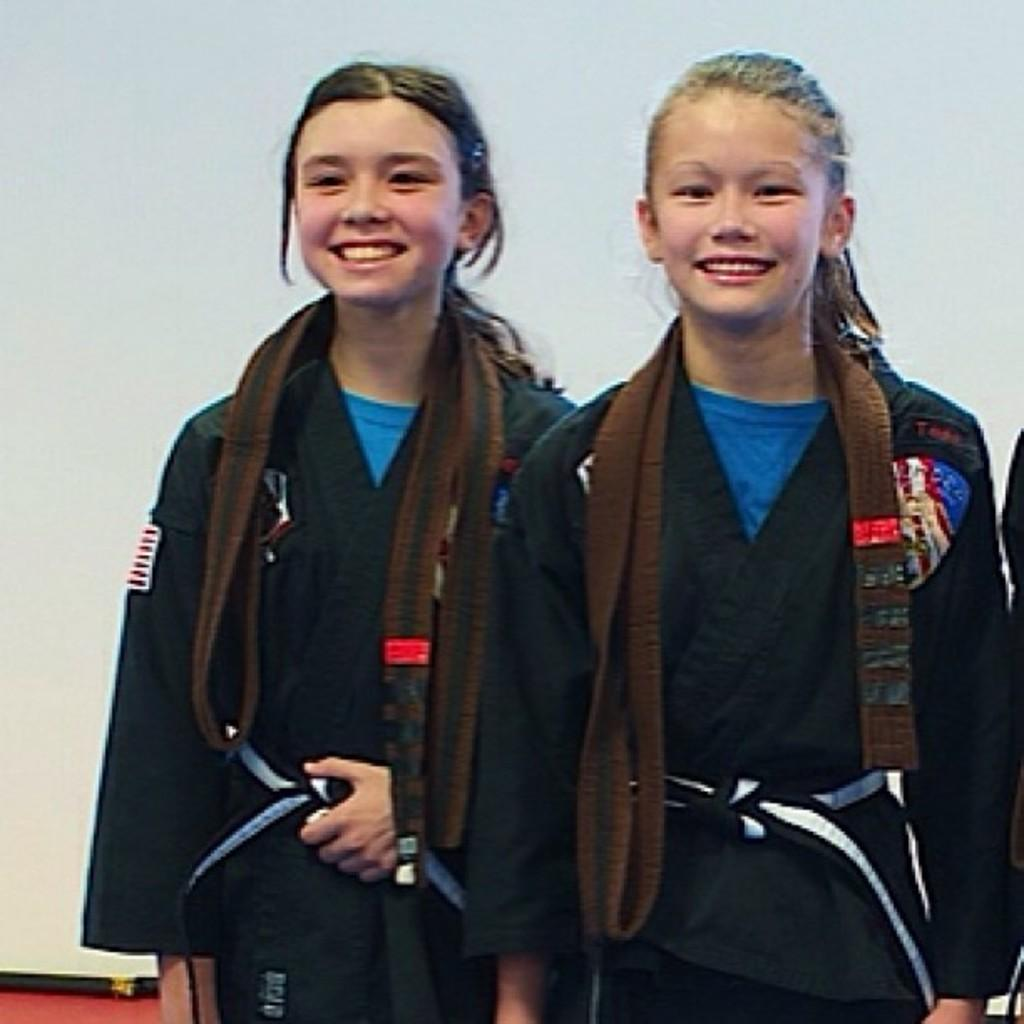How many people are in the image? There are two girls in the image. What are the girls doing in the image? The girls are standing and smiling. What is the color of the background in the image? The background behind the girls is white. What type of wilderness can be seen in the background of the image? There is no wilderness visible in the image; the background is a solid white color. 